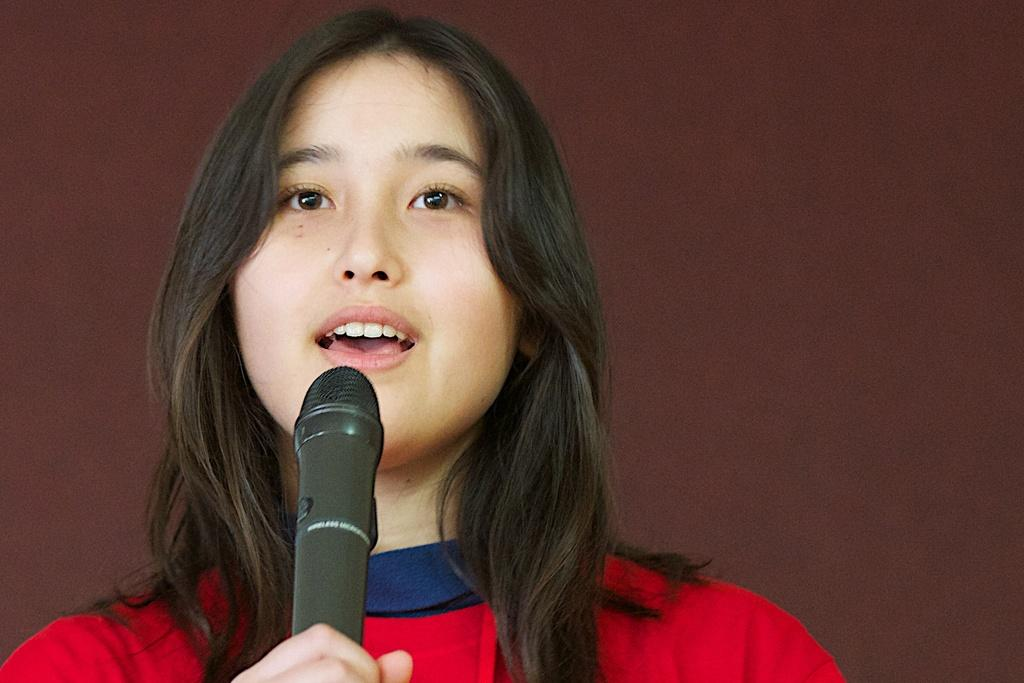Who is the main subject in the image? There is a girl in the image. What is the girl doing in the image? The girl is standing in the image. What object is the girl holding in her hand? The girl is holding a mic in her hand. What type of carriage can be seen in the background of the image? There is no carriage present in the image; it only features a girl standing and holding a mic. 